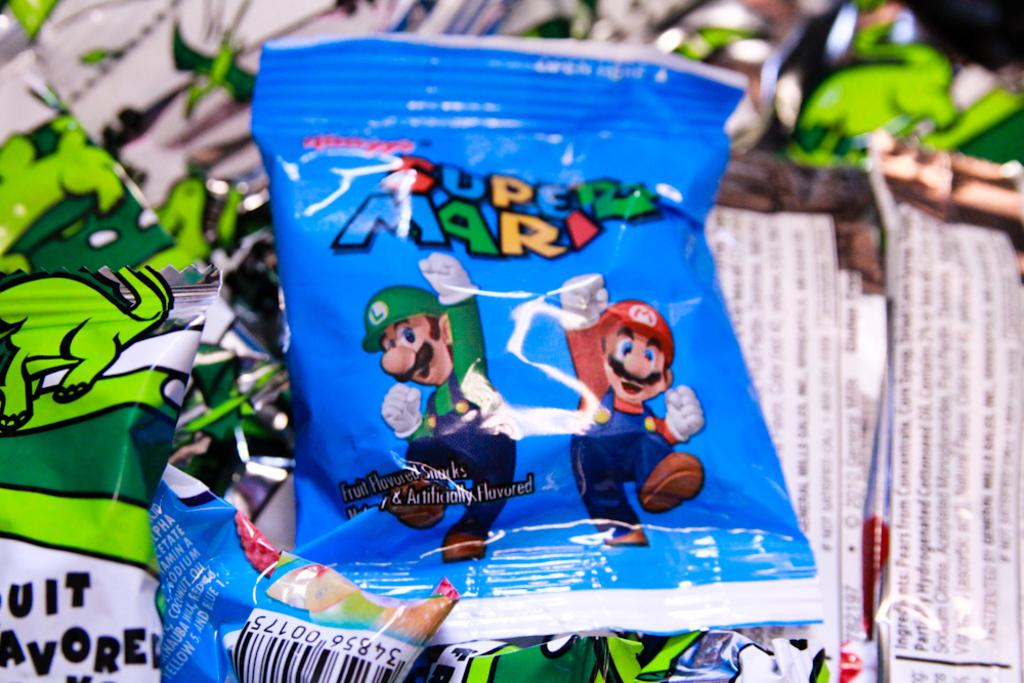What objects are present in the image? There are packets in the image. Can you describe the appearance of the packets? The packets are blue and green in color. Is there a kettle in the image? No, there is no kettle present in the image. Can you tell me when the birth of the tiger occurred in the image? There is no tiger or any reference to a birth in the image. 